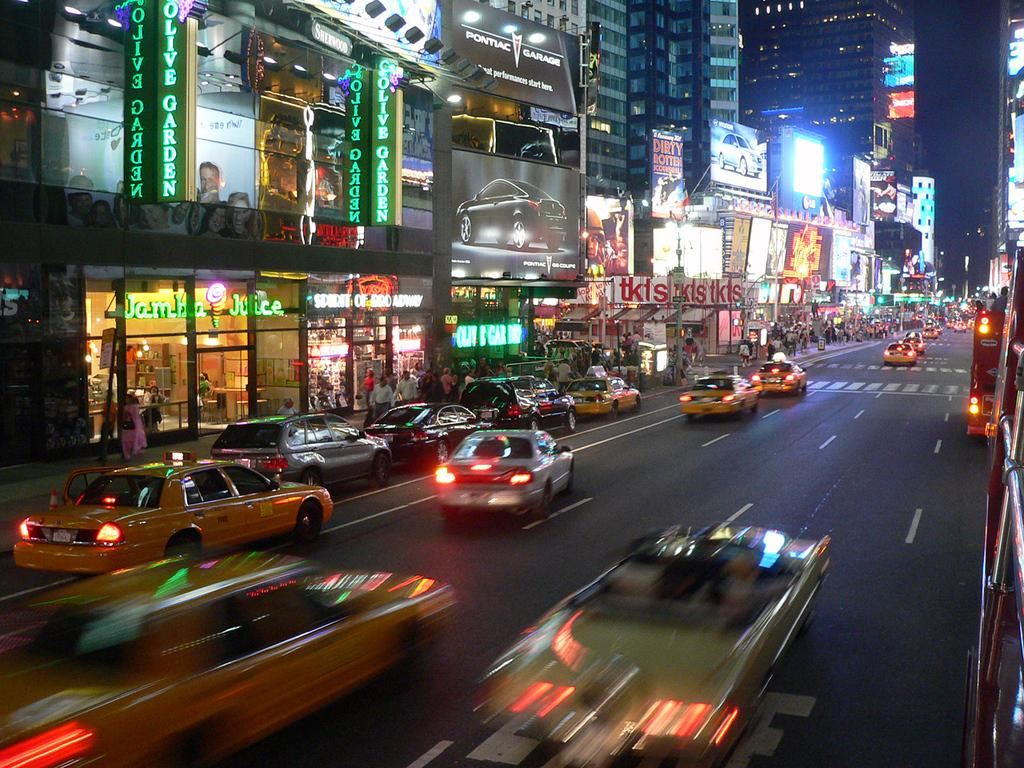<image>
Relay a brief, clear account of the picture shown. A night-time cityscape shows that Jamba Juice is just below the Olive Garden. 